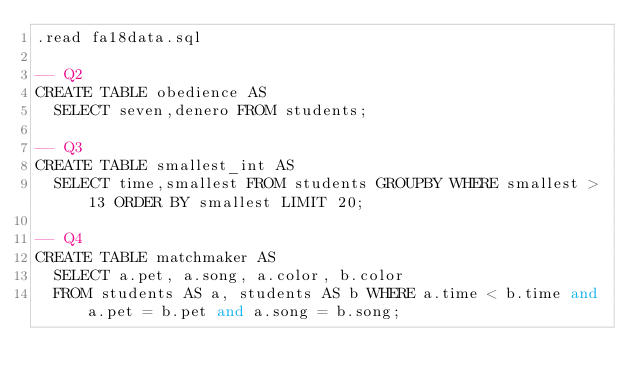Convert code to text. <code><loc_0><loc_0><loc_500><loc_500><_SQL_>.read fa18data.sql

-- Q2
CREATE TABLE obedience AS
  SELECT seven,denero FROM students;

-- Q3
CREATE TABLE smallest_int AS
  SELECT time,smallest FROM students GROUPBY WHERE smallest > 13 ORDER BY smallest LIMIT 20;

-- Q4
CREATE TABLE matchmaker AS
  SELECT a.pet, a.song, a.color, b.color
  FROM students AS a, students AS b WHERE a.time < b.time and a.pet = b.pet and a.song = b.song;
</code> 